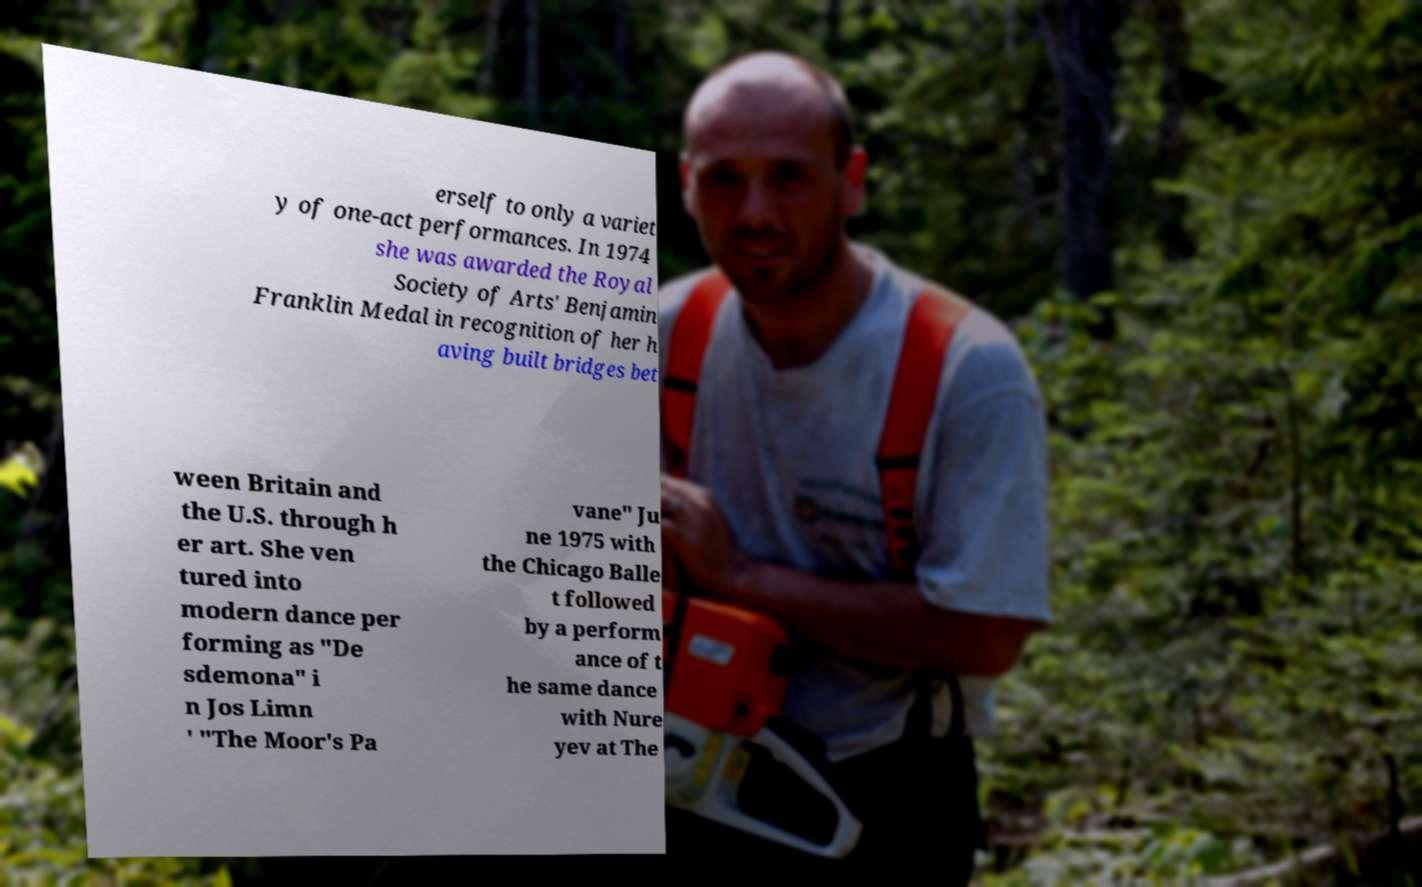Can you read and provide the text displayed in the image?This photo seems to have some interesting text. Can you extract and type it out for me? erself to only a variet y of one-act performances. In 1974 she was awarded the Royal Society of Arts' Benjamin Franklin Medal in recognition of her h aving built bridges bet ween Britain and the U.S. through h er art. She ven tured into modern dance per forming as "De sdemona" i n Jos Limn ' "The Moor's Pa vane" Ju ne 1975 with the Chicago Balle t followed by a perform ance of t he same dance with Nure yev at The 